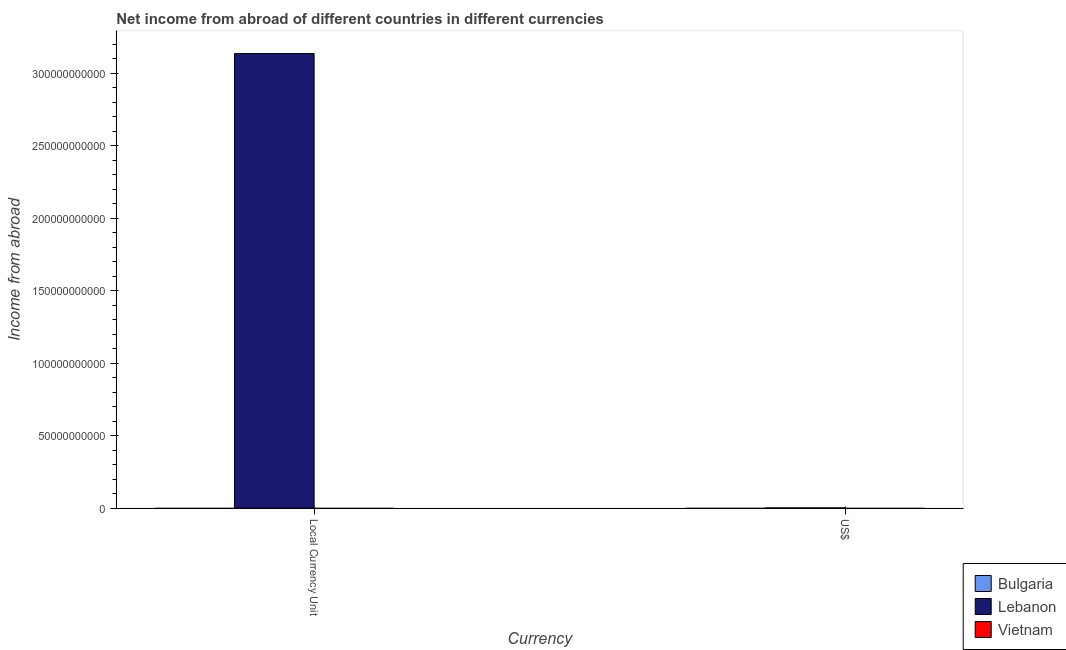How many different coloured bars are there?
Your response must be concise. 1. Are the number of bars per tick equal to the number of legend labels?
Your answer should be very brief. No. Are the number of bars on each tick of the X-axis equal?
Your answer should be compact. Yes. How many bars are there on the 2nd tick from the left?
Offer a terse response. 1. How many bars are there on the 2nd tick from the right?
Make the answer very short. 1. What is the label of the 2nd group of bars from the left?
Give a very brief answer. US$. What is the income from abroad in us$ in Lebanon?
Give a very brief answer. 2.08e+08. Across all countries, what is the maximum income from abroad in us$?
Ensure brevity in your answer.  2.08e+08. Across all countries, what is the minimum income from abroad in constant 2005 us$?
Provide a succinct answer. 0. In which country was the income from abroad in us$ maximum?
Offer a very short reply. Lebanon. What is the total income from abroad in constant 2005 us$ in the graph?
Your answer should be compact. 3.14e+11. What is the difference between the income from abroad in us$ in Lebanon and the income from abroad in constant 2005 us$ in Bulgaria?
Offer a terse response. 2.08e+08. What is the average income from abroad in constant 2005 us$ per country?
Keep it short and to the point. 1.05e+11. What is the difference between the income from abroad in constant 2005 us$ and income from abroad in us$ in Lebanon?
Make the answer very short. 3.13e+11. In how many countries, is the income from abroad in constant 2005 us$ greater than 310000000000 units?
Give a very brief answer. 1. How many bars are there?
Your answer should be compact. 2. Are all the bars in the graph horizontal?
Give a very brief answer. No. Does the graph contain grids?
Give a very brief answer. No. Where does the legend appear in the graph?
Your answer should be very brief. Bottom right. How many legend labels are there?
Offer a terse response. 3. What is the title of the graph?
Give a very brief answer. Net income from abroad of different countries in different currencies. What is the label or title of the X-axis?
Offer a terse response. Currency. What is the label or title of the Y-axis?
Offer a terse response. Income from abroad. What is the Income from abroad in Bulgaria in Local Currency Unit?
Ensure brevity in your answer.  0. What is the Income from abroad in Lebanon in Local Currency Unit?
Provide a succinct answer. 3.14e+11. What is the Income from abroad in Lebanon in US$?
Offer a terse response. 2.08e+08. What is the Income from abroad in Vietnam in US$?
Offer a very short reply. 0. Across all Currency, what is the maximum Income from abroad in Lebanon?
Your response must be concise. 3.14e+11. Across all Currency, what is the minimum Income from abroad in Lebanon?
Make the answer very short. 2.08e+08. What is the total Income from abroad in Bulgaria in the graph?
Provide a short and direct response. 0. What is the total Income from abroad in Lebanon in the graph?
Ensure brevity in your answer.  3.14e+11. What is the difference between the Income from abroad of Lebanon in Local Currency Unit and that in US$?
Offer a terse response. 3.13e+11. What is the average Income from abroad of Bulgaria per Currency?
Ensure brevity in your answer.  0. What is the average Income from abroad in Lebanon per Currency?
Ensure brevity in your answer.  1.57e+11. What is the average Income from abroad in Vietnam per Currency?
Offer a very short reply. 0. What is the ratio of the Income from abroad of Lebanon in Local Currency Unit to that in US$?
Your answer should be very brief. 1507.84. What is the difference between the highest and the second highest Income from abroad of Lebanon?
Keep it short and to the point. 3.13e+11. What is the difference between the highest and the lowest Income from abroad in Lebanon?
Offer a very short reply. 3.13e+11. 